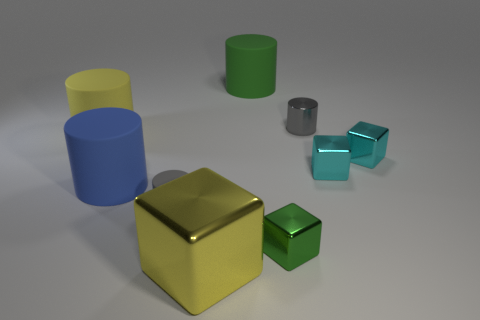Is there any other thing that has the same size as the yellow matte cylinder?
Your answer should be very brief. Yes. Is the color of the small matte cylinder the same as the big cube?
Your answer should be compact. No. The large rubber cylinder that is to the right of the metallic cube that is to the left of the green cylinder is what color?
Keep it short and to the point. Green. How many small things are either things or yellow cylinders?
Provide a short and direct response. 5. What color is the cube that is right of the big green object and left of the gray shiny thing?
Your answer should be very brief. Green. Does the yellow cylinder have the same material as the green cylinder?
Your answer should be compact. Yes. The tiny green metal thing is what shape?
Make the answer very short. Cube. There is a shiny thing left of the matte cylinder behind the big yellow matte cylinder; how many green matte cylinders are behind it?
Your answer should be very brief. 1. What color is the large shiny thing that is the same shape as the tiny green metal thing?
Your answer should be very brief. Yellow. There is a yellow thing on the right side of the yellow thing that is on the left side of the big yellow thing that is in front of the blue matte thing; what shape is it?
Offer a terse response. Cube. 